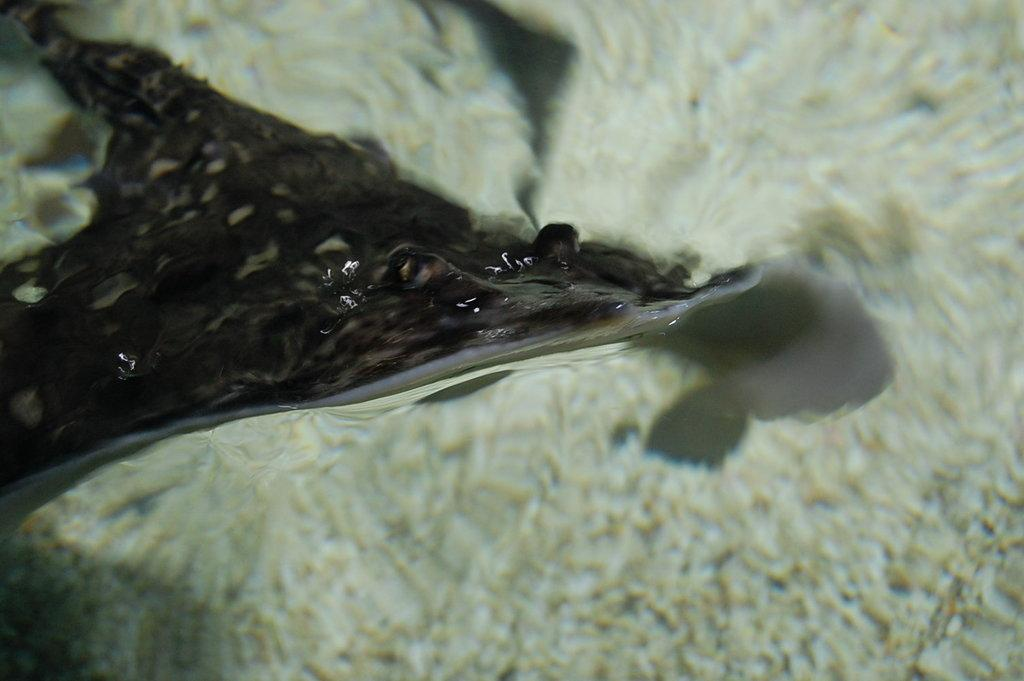What type of creature can be seen in the image? There is an underwater creature in the image. What type of fork can be seen in the image? There is no fork present in the image; it features an underwater creature. What is the position of the moon in the image? There is no moon present in the image; it features an underwater creature. 